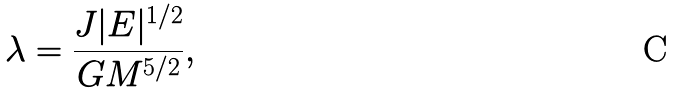<formula> <loc_0><loc_0><loc_500><loc_500>\lambda = \frac { J | E | ^ { 1 / 2 } } { G M ^ { 5 / 2 } } ,</formula> 